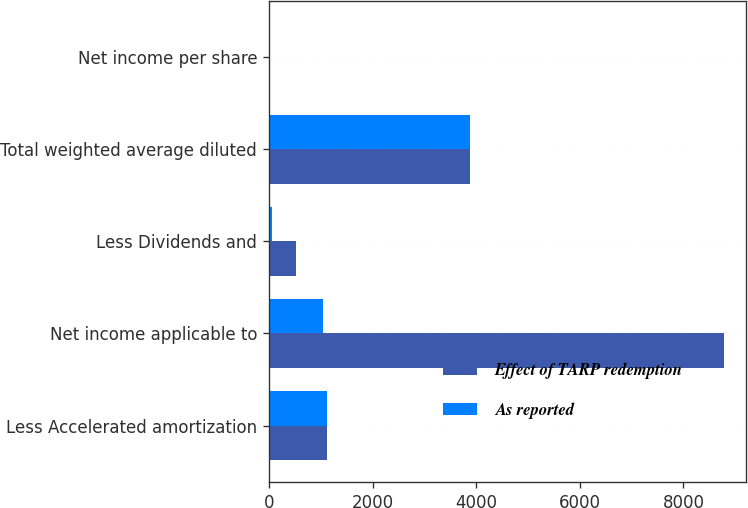Convert chart. <chart><loc_0><loc_0><loc_500><loc_500><stacked_bar_chart><ecel><fcel>Less Accelerated amortization<fcel>Net income applicable to<fcel>Less Dividends and<fcel>Total weighted average diluted<fcel>Net income per share<nl><fcel>Effect of TARP redemption<fcel>1112<fcel>8774<fcel>515<fcel>3879.7<fcel>2.26<nl><fcel>As reported<fcel>1112<fcel>1050<fcel>62<fcel>3879.7<fcel>0.27<nl></chart> 